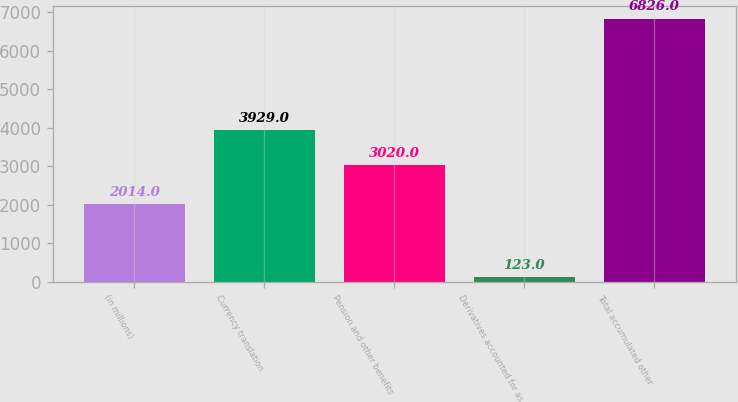Convert chart to OTSL. <chart><loc_0><loc_0><loc_500><loc_500><bar_chart><fcel>(in millions)<fcel>Currency translation<fcel>Pension and other benefits<fcel>Derivatives accounted for as<fcel>Total accumulated other<nl><fcel>2014<fcel>3929<fcel>3020<fcel>123<fcel>6826<nl></chart> 